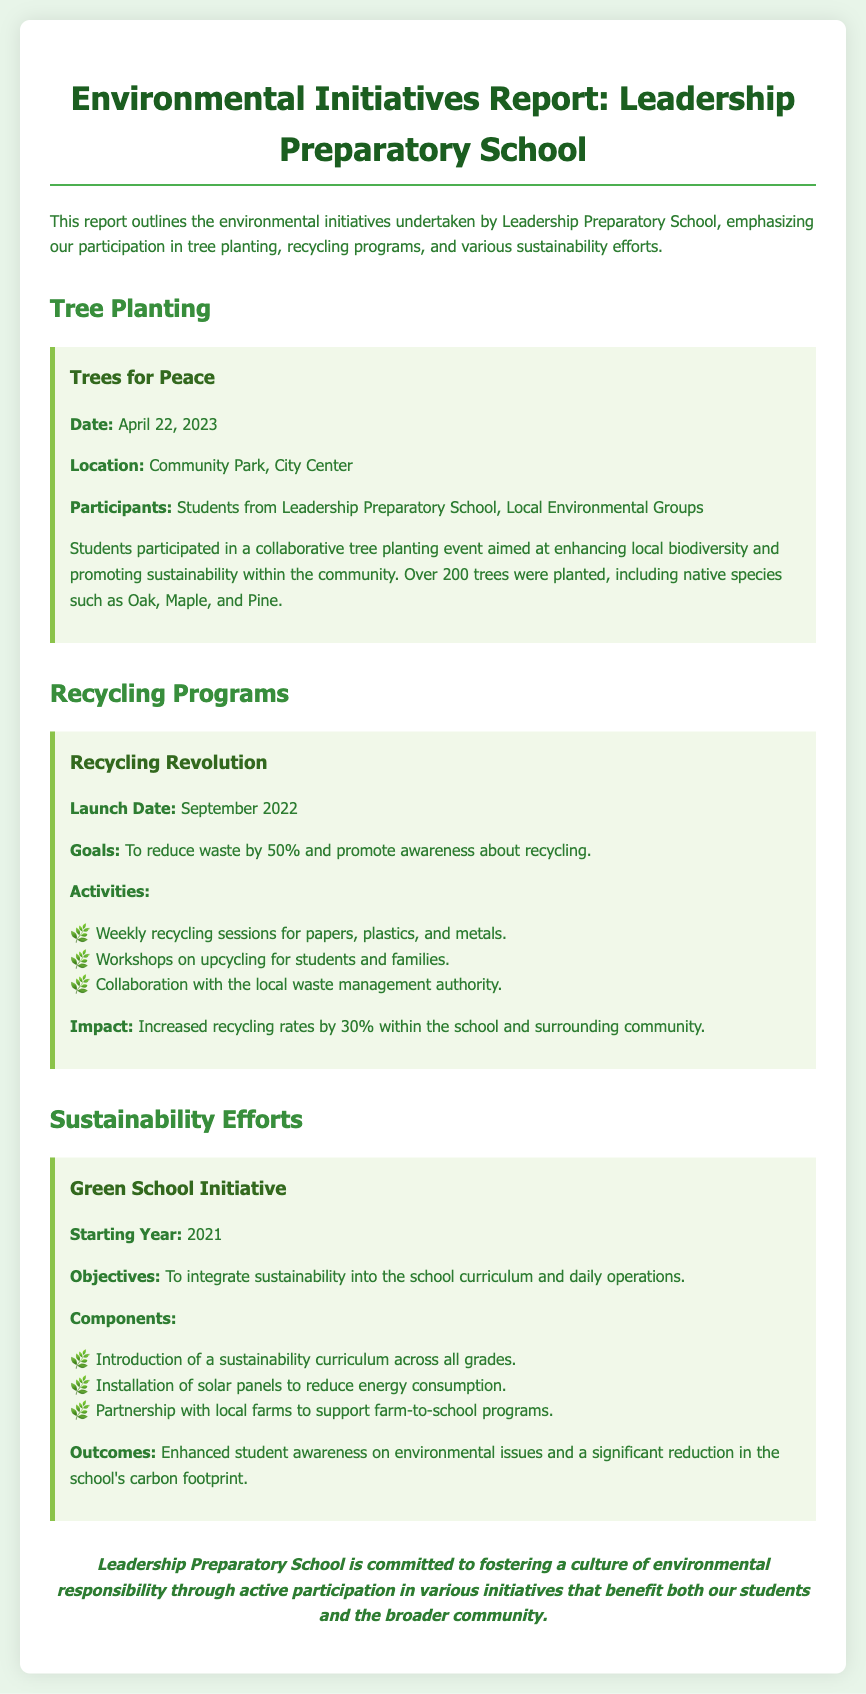What is the name of the tree planting event? The event is titled "Trees for Peace," as stated in the document.
Answer: Trees for Peace When did the tree planting event occur? The document specifies that the event took place on April 22, 2023.
Answer: April 22, 2023 What was the primary goal of the Recycling Revolution? The goal mentioned is to reduce waste by 50% and promote awareness about recycling.
Answer: Reduce waste by 50% How many trees were planted during the event? The document states that over 200 trees were planted during the event.
Answer: Over 200 trees What is one of the components of the Green School Initiative? The document lists several components, one of which is the introduction of a sustainability curriculum.
Answer: Sustainability curriculum What was the impact of the Recycling Revolution program? The document notes that there was a 30% increase in recycling rates within the school and community.
Answer: Increased recycling rates by 30% Where was the tree planting event located? The document indicates that the event took place at Community Park, City Center.
Answer: Community Park, City Center What year did the Green School Initiative start? According to the document, the initiative started in 2021.
Answer: 2021 Who participated in the Trees for Peace event? The participants included students from Leadership Preparatory School and local environmental groups.
Answer: Students from Leadership Preparatory School, Local Environmental Groups 